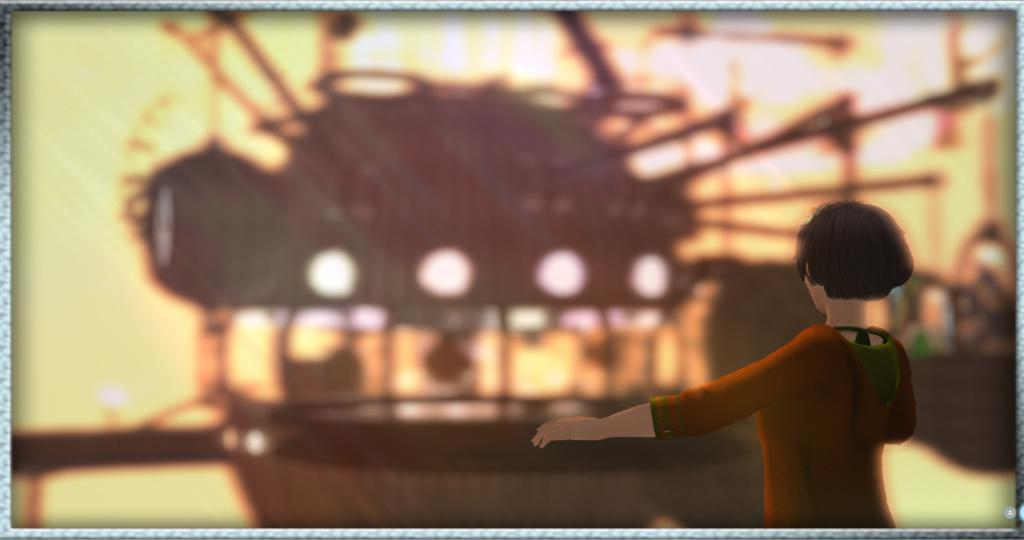What type of image is depicted in the picture? The image is an animated picture. Can you describe the main subject in the image? There is a cartoon person in the image. How is the background of the image depicted? The background of the image is blurred. Can you tell me how many roses are on the table in the image? There are no roses or table present in the image; it features an animated cartoon person. What type of coat is the cartoon person wearing in the image? The cartoon person in the image is not wearing a coat, as it is an animated picture and not a realistic depiction. 